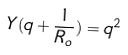Convert formula to latex. <formula><loc_0><loc_0><loc_500><loc_500>Y ( q + \frac { 1 } { R _ { o } } ) = q ^ { 2 }</formula> 